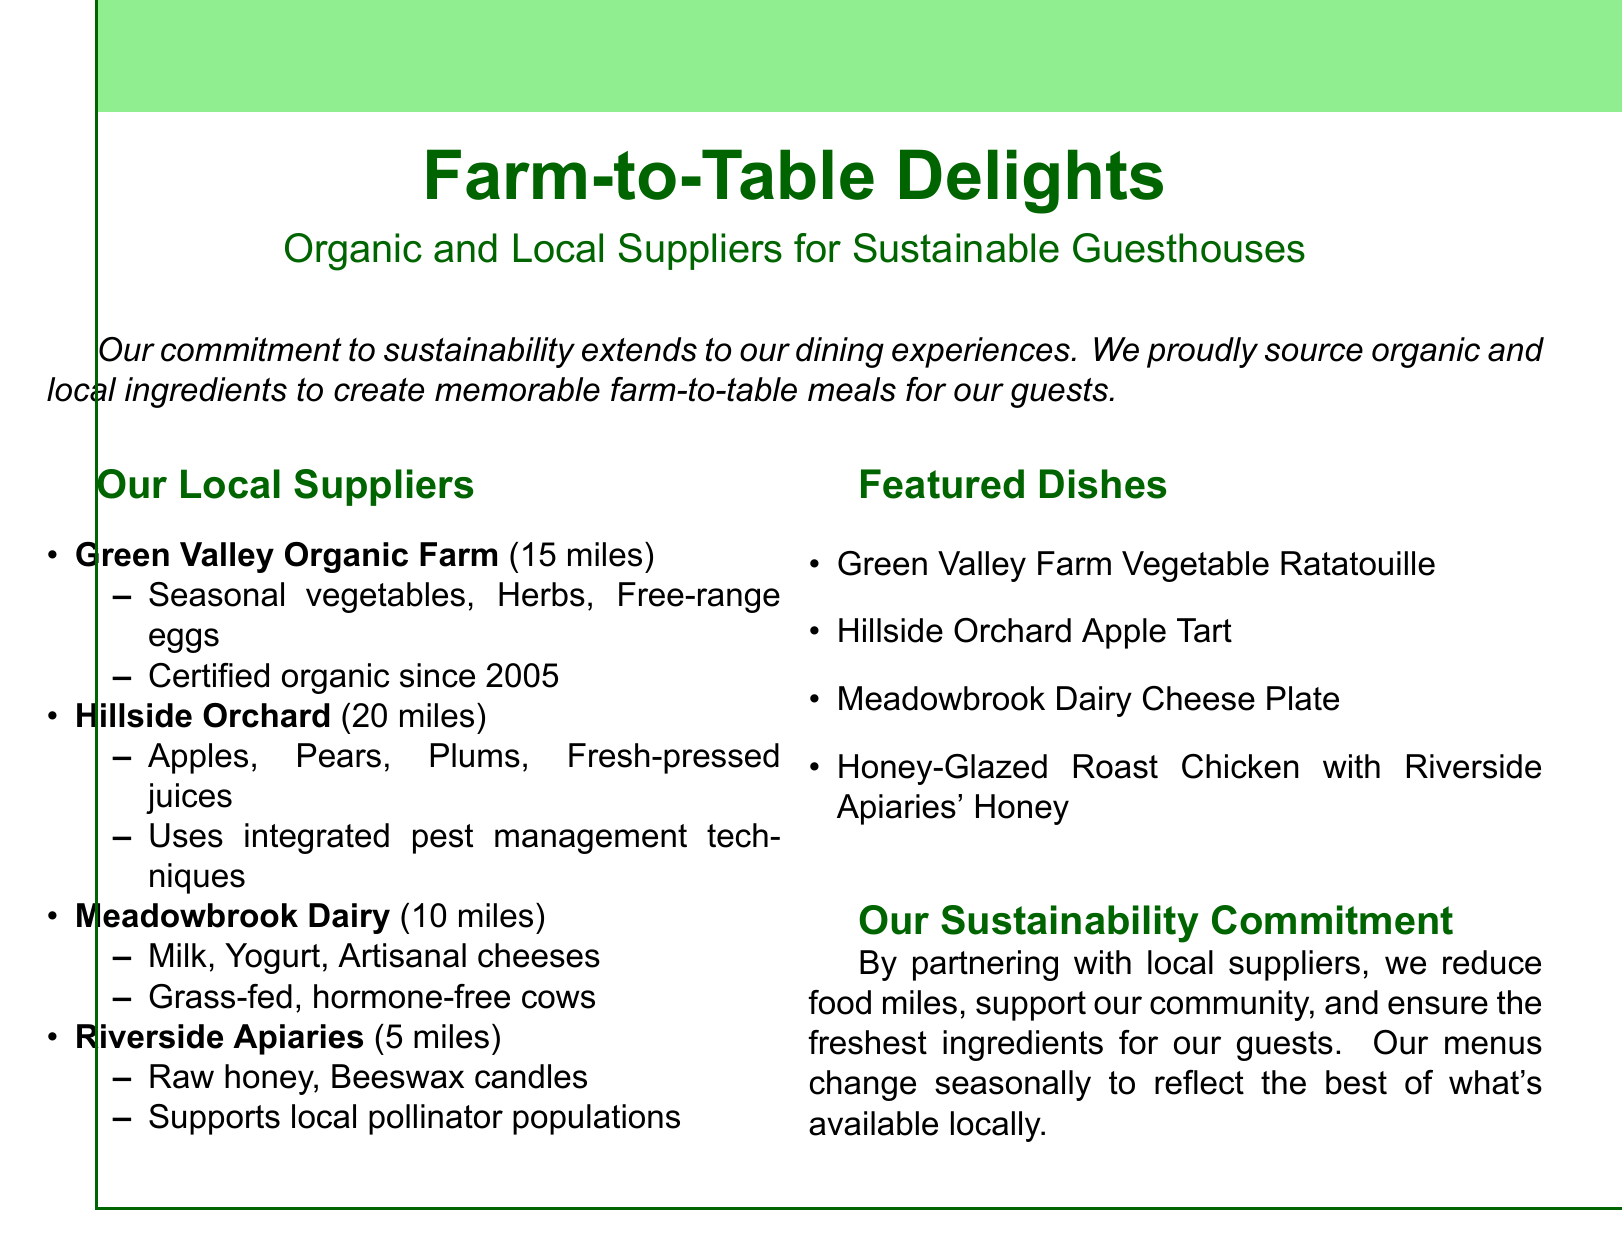What is the name of the farm that provides seasonal vegetables? The document lists "Green Valley Organic Farm" as the supplier of seasonal vegetables.
Answer: Green Valley Organic Farm How far is Riverside Apiaries from the guesthouse? Riverside Apiaries is mentioned to be 5 miles away from the guesthouse.
Answer: 5 miles Which supplier is known for artisanal cheeses? "Meadowbrook Dairy" is identified as the supplier for artisanal cheeses.
Answer: Meadowbrook Dairy What type of fruit does Hillside Orchard provide? The document specifies that Hillside Orchard supplies apples, pears, and plums.
Answer: Apples, Pears, Plums What dish features honey from Riverside Apiaries? The document states that "Honey-Glazed Roast Chicken" includes honey from Riverside Apiaries.
Answer: Honey-Glazed Roast Chicken How many miles away is Meadowbrook Dairy? The document specifies that Meadowbrook Dairy is 10 miles away from the guesthouse.
Answer: 10 miles What is the commitment mentioned in the document? The sustainability commitment focuses on reducing food miles, supporting the community, and ensuring fresh ingredients.
Answer: Sustainable commitment Name one dish that utilizes ingredients from Green Valley Organic Farm. "Green Valley Farm Vegetable Ratatouille" is specifically mentioned as a dish that uses ingredients from there.
Answer: Green Valley Farm Vegetable Ratatouille What year did Green Valley Organic Farm become certified organic? The document states that Green Valley Organic Farm has been certified organic since 2005.
Answer: 2005 